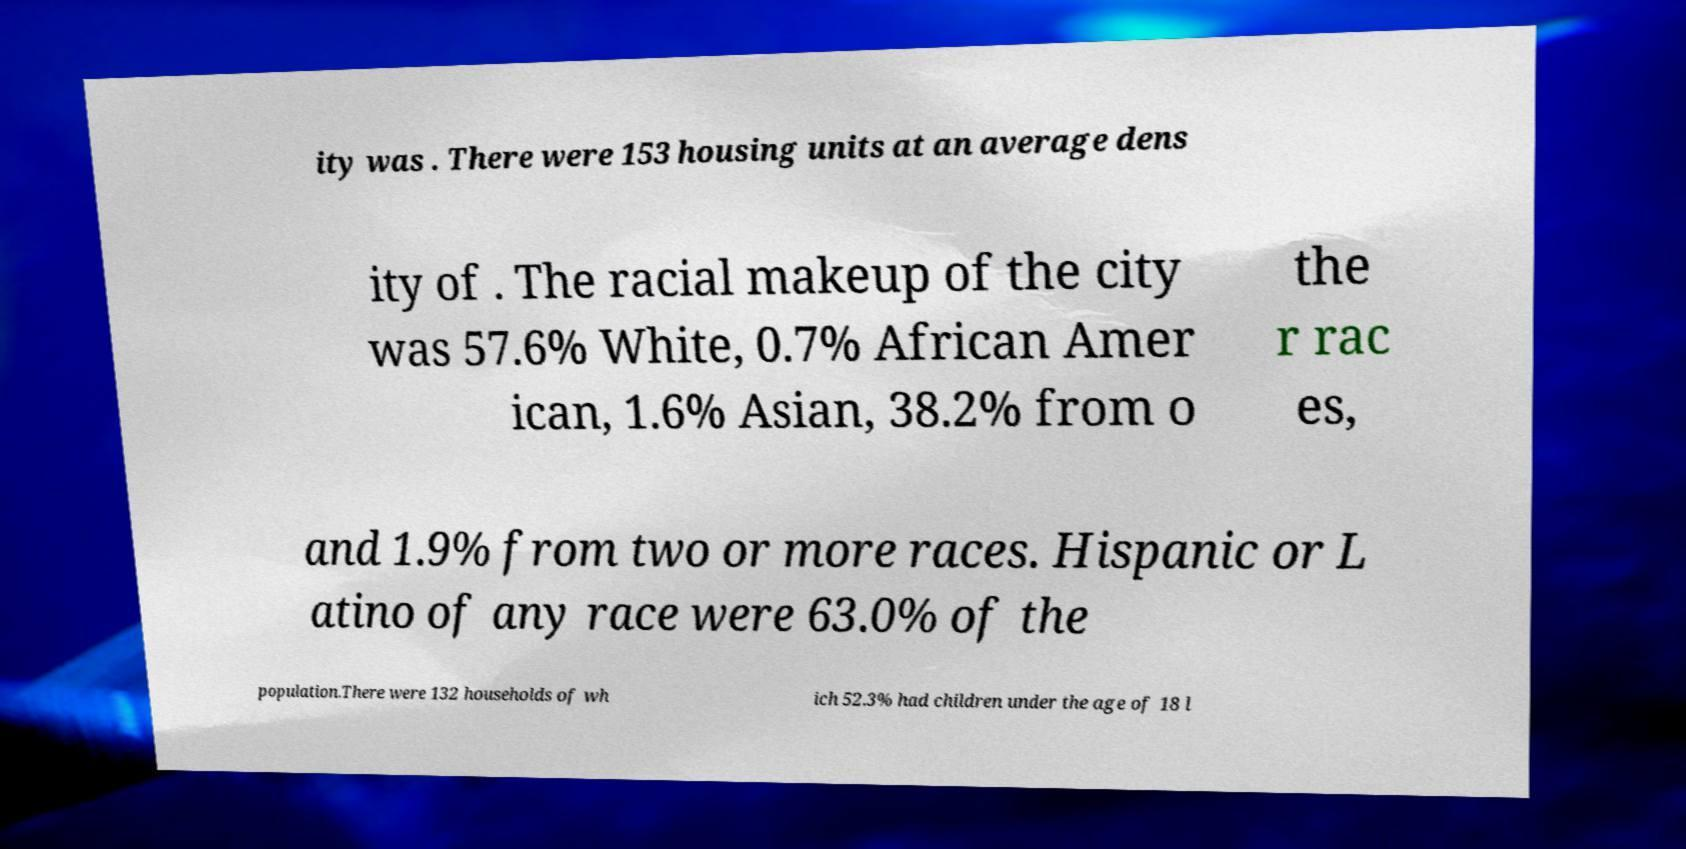There's text embedded in this image that I need extracted. Can you transcribe it verbatim? ity was . There were 153 housing units at an average dens ity of . The racial makeup of the city was 57.6% White, 0.7% African Amer ican, 1.6% Asian, 38.2% from o the r rac es, and 1.9% from two or more races. Hispanic or L atino of any race were 63.0% of the population.There were 132 households of wh ich 52.3% had children under the age of 18 l 